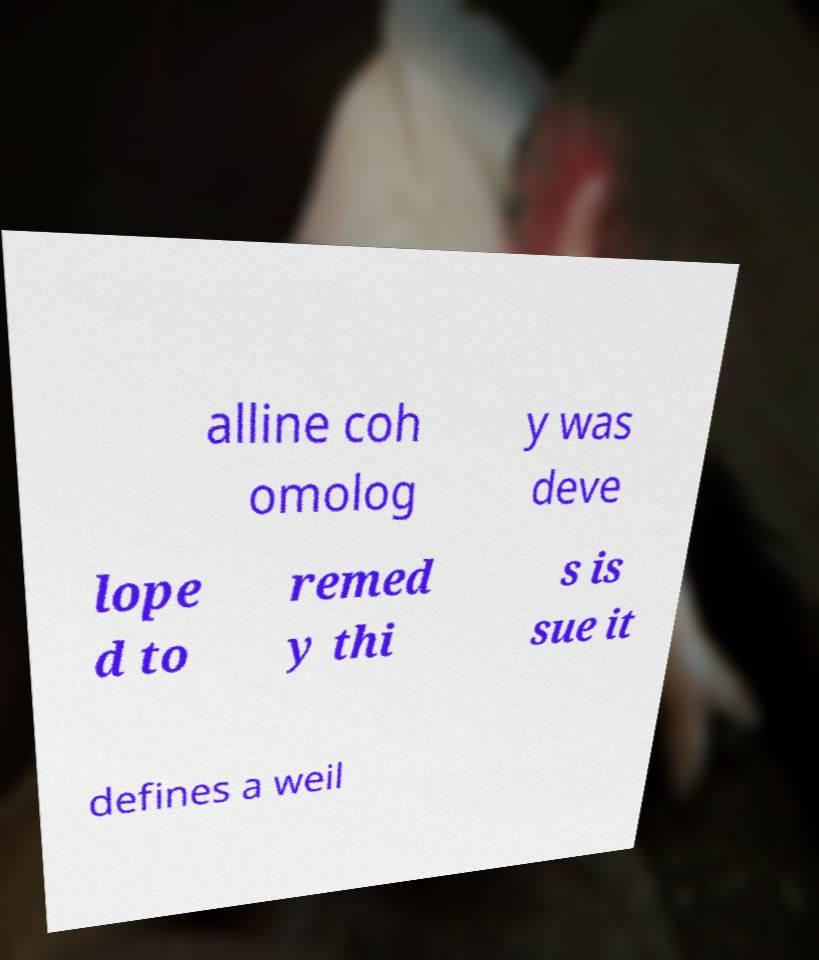There's text embedded in this image that I need extracted. Can you transcribe it verbatim? alline coh omolog y was deve lope d to remed y thi s is sue it defines a weil 